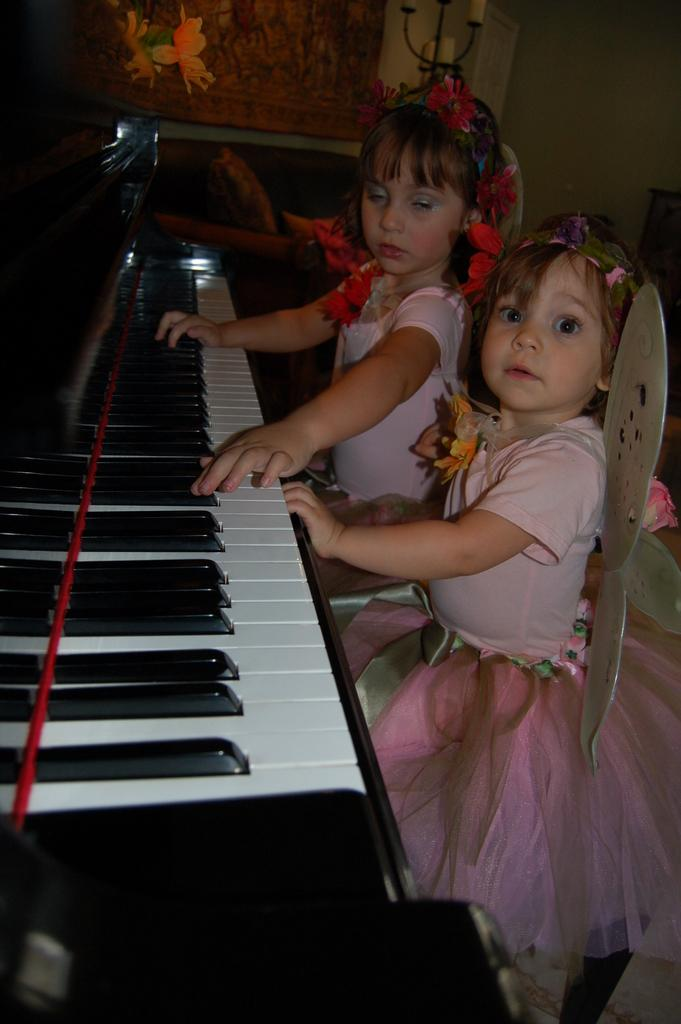How many girls are in the image? There are two girls in the image. What are the girls wearing? Both girls are wearing angel dresses. What is one of the girls doing in the image? One of the girls is playing a piano. What can be seen in the background of the image? There is a painting of flowers in the background. Can you tell me the color of the kitten's fur in the image? There is no kitten present in the image. What type of polish is the mom applying to her nails in the image? There is no mom or nail polish present in the image. 